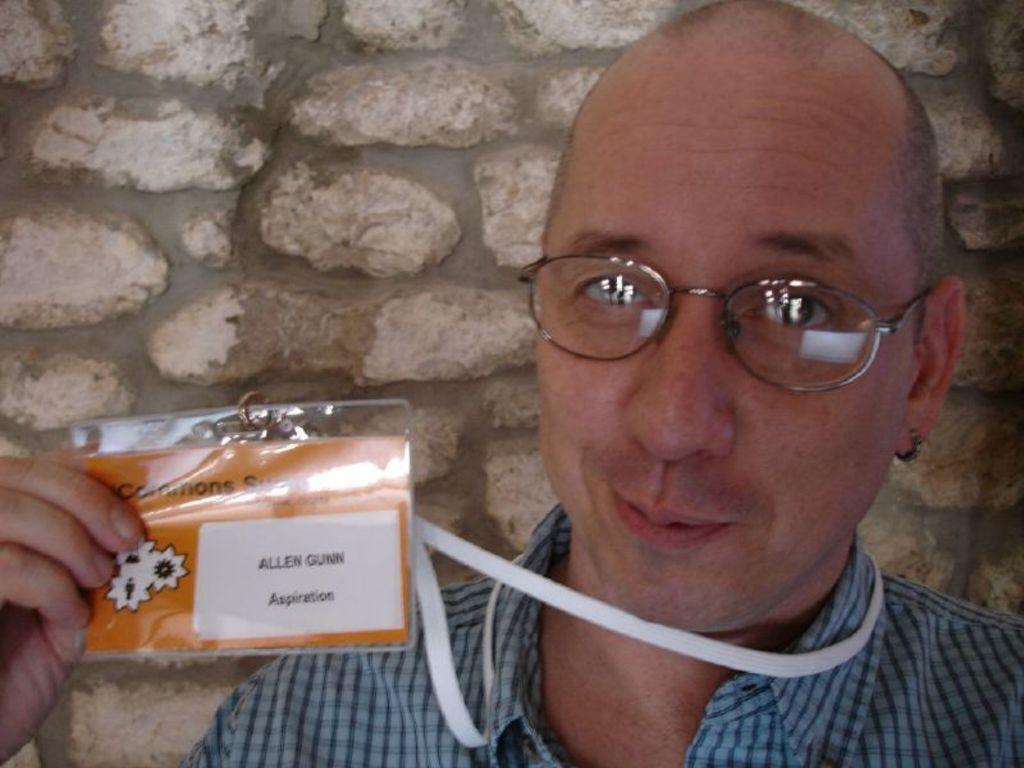Can you describe this image briefly? In this picture we can observe a person wearing spectacles and smiling. He is holding an id card in his hand. In the background there is a stone wall. 